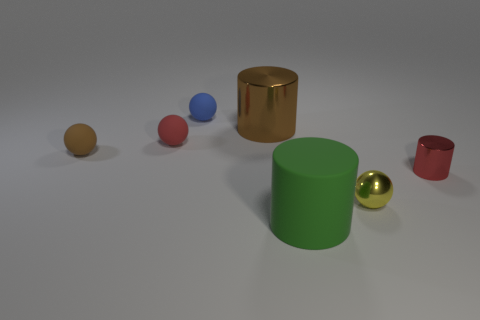Add 3 yellow cylinders. How many objects exist? 10 Subtract all brown cylinders. How many cylinders are left? 2 Add 4 blue rubber spheres. How many blue rubber spheres are left? 5 Add 1 big blue cylinders. How many big blue cylinders exist? 1 Subtract all blue spheres. How many spheres are left? 3 Subtract 0 blue blocks. How many objects are left? 7 Subtract all cylinders. How many objects are left? 4 Subtract 2 balls. How many balls are left? 2 Subtract all blue cylinders. Subtract all cyan cubes. How many cylinders are left? 3 Subtract all cyan cylinders. How many red balls are left? 1 